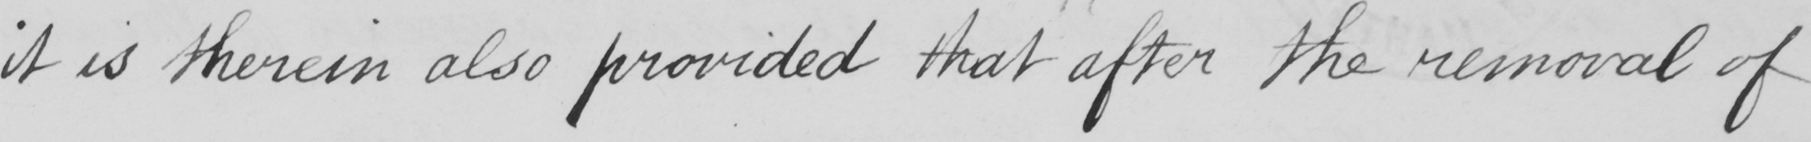Can you read and transcribe this handwriting? it is therein also provided that after the removal of 